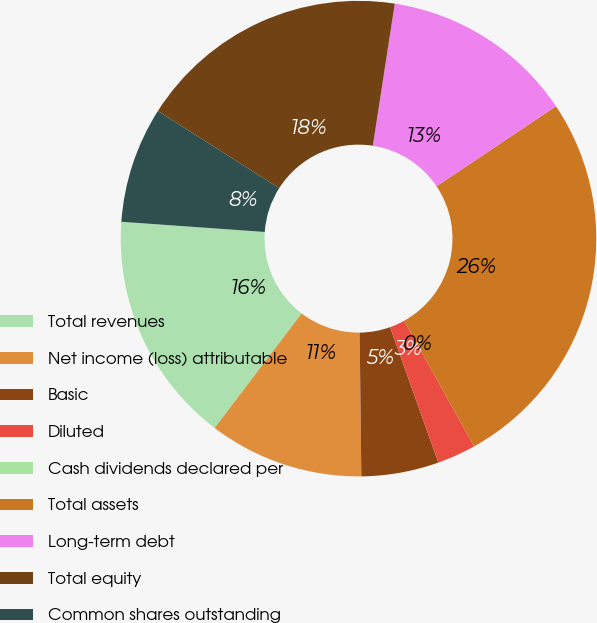<chart> <loc_0><loc_0><loc_500><loc_500><pie_chart><fcel>Total revenues<fcel>Net income (loss) attributable<fcel>Basic<fcel>Diluted<fcel>Cash dividends declared per<fcel>Total assets<fcel>Long-term debt<fcel>Total equity<fcel>Common shares outstanding<nl><fcel>15.79%<fcel>10.53%<fcel>5.26%<fcel>2.63%<fcel>0.0%<fcel>26.32%<fcel>13.16%<fcel>18.42%<fcel>7.89%<nl></chart> 